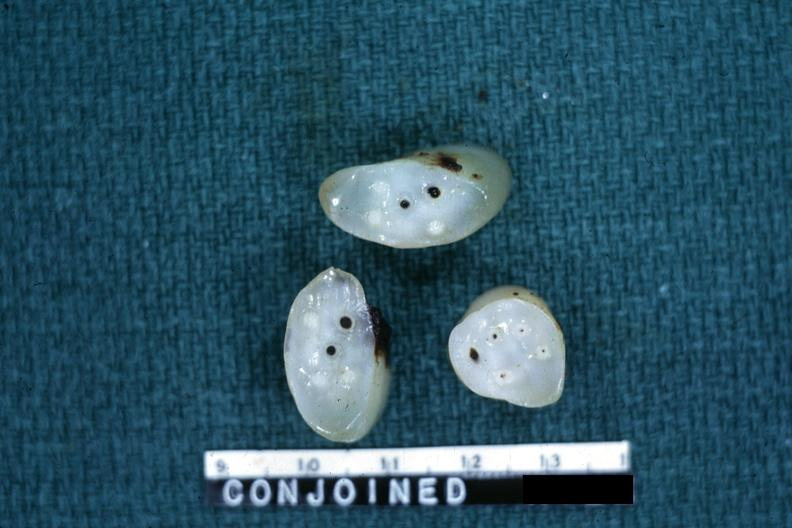s siamese twins present?
Answer the question using a single word or phrase. Yes 